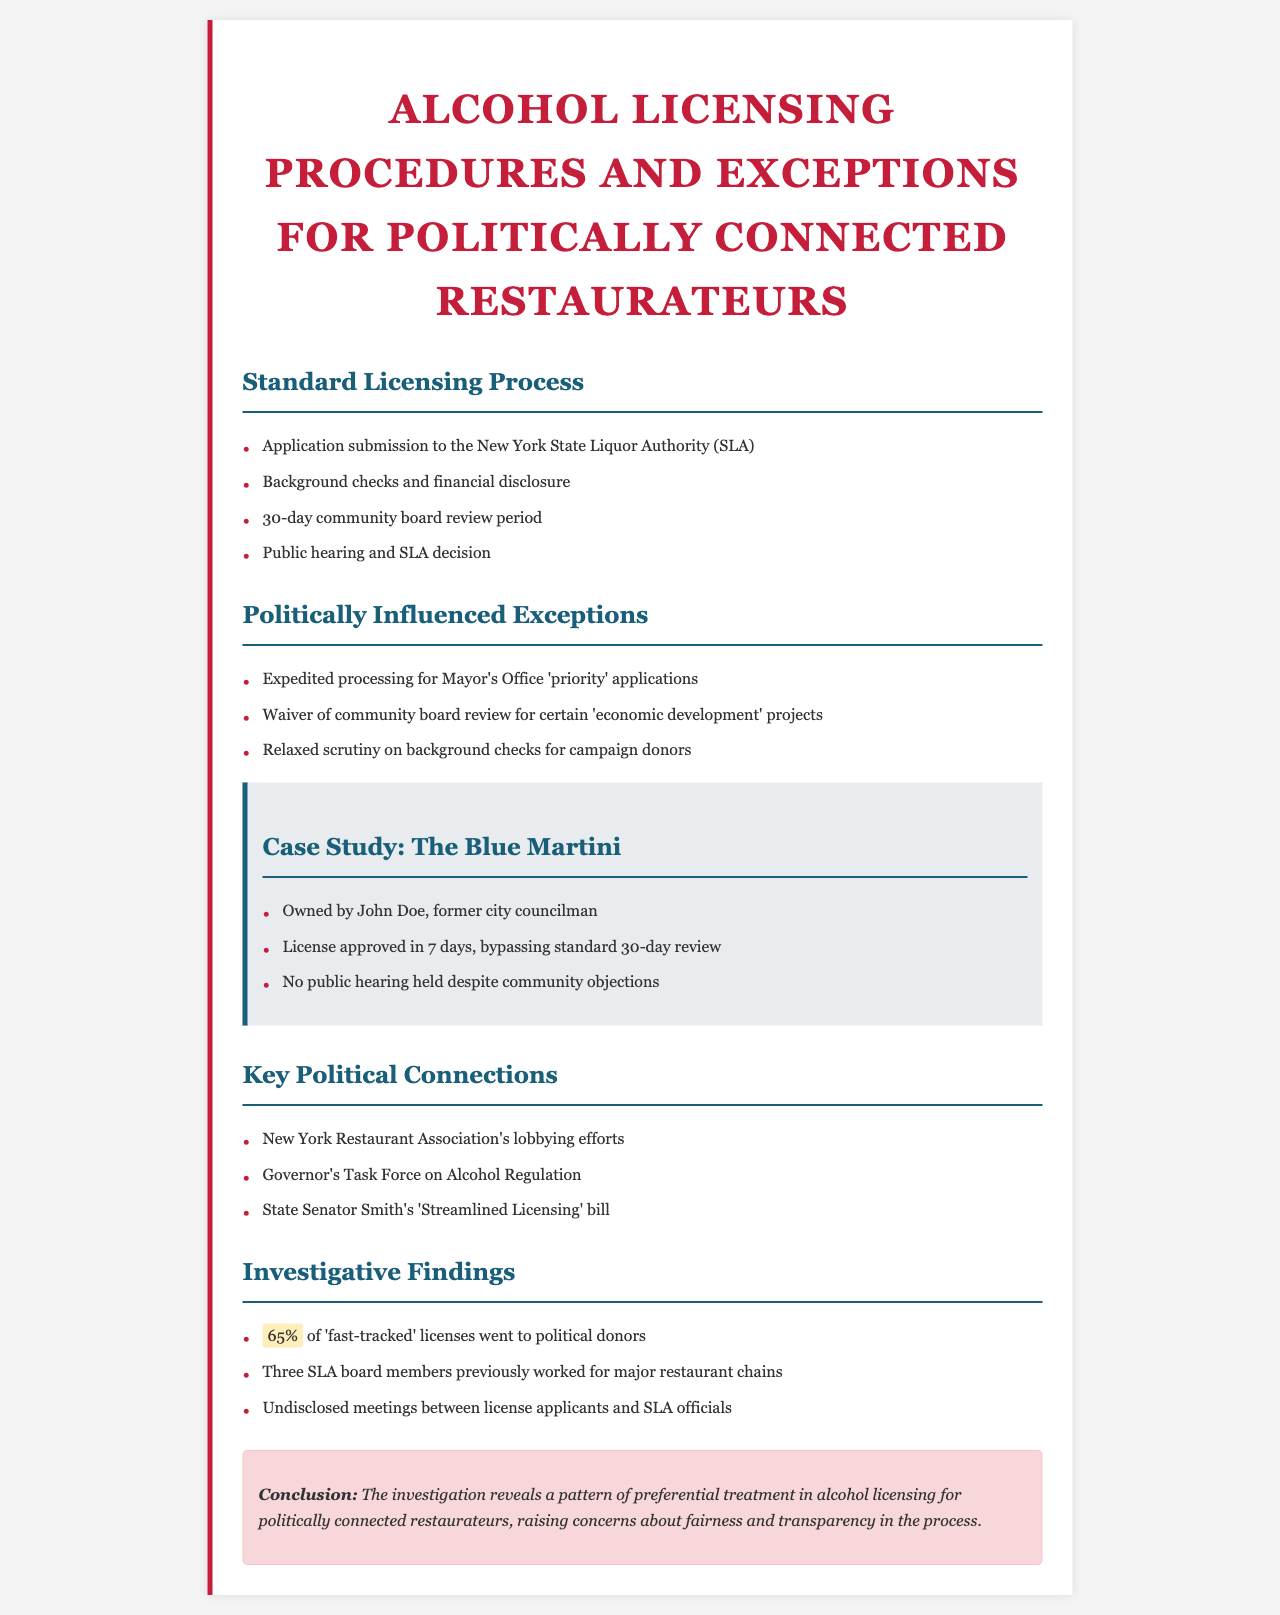What is the standard community board review period? The document states that the standard community board review period is 30 days.
Answer: 30 days Who owned The Blue Martini? The case study indicates that The Blue Martini is owned by John Doe.
Answer: John Doe What percentage of 'fast-tracked' licenses went to political donors? According to the investigative findings, 65% of 'fast-tracked' licenses went to political donors.
Answer: 65% What was bypassed in the licensing process for The Blue Martini? The document mentions that The Blue Martini's license was approved in 7 days, bypassing the standard 30-day review.
Answer: 30-day review Which office receives 'priority' applications? The document refers to the Mayor's Office as the recipient of 'priority' applications.
Answer: Mayor's Office What type of projects can waive community board review? The document states that certain 'economic development' projects can waive community board review.
Answer: Economic development projects Who is associated with the 'Streamlined Licensing' bill? The document lists State Senator Smith as associated with the 'Streamlined Licensing' bill.
Answer: State Senator Smith What is one concern raised in the conclusion? The conclusion expresses concerns about fairness and transparency in the licensing process.
Answer: Fairness and transparency How many SLA board members previously worked for major restaurant chains? The investigative findings report that three SLA board members previously worked for major restaurant chains.
Answer: Three 